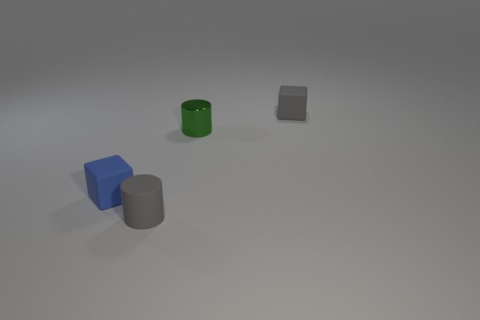Add 1 gray rubber cylinders. How many objects exist? 5 Subtract all green cylinders. How many cylinders are left? 1 Subtract 2 blocks. How many blocks are left? 0 Subtract all purple cylinders. Subtract all brown balls. How many cylinders are left? 2 Subtract all gray blocks. How many gray cylinders are left? 1 Subtract all gray blocks. Subtract all green metallic cylinders. How many objects are left? 2 Add 3 gray cylinders. How many gray cylinders are left? 4 Add 3 gray cylinders. How many gray cylinders exist? 4 Subtract 0 brown cylinders. How many objects are left? 4 